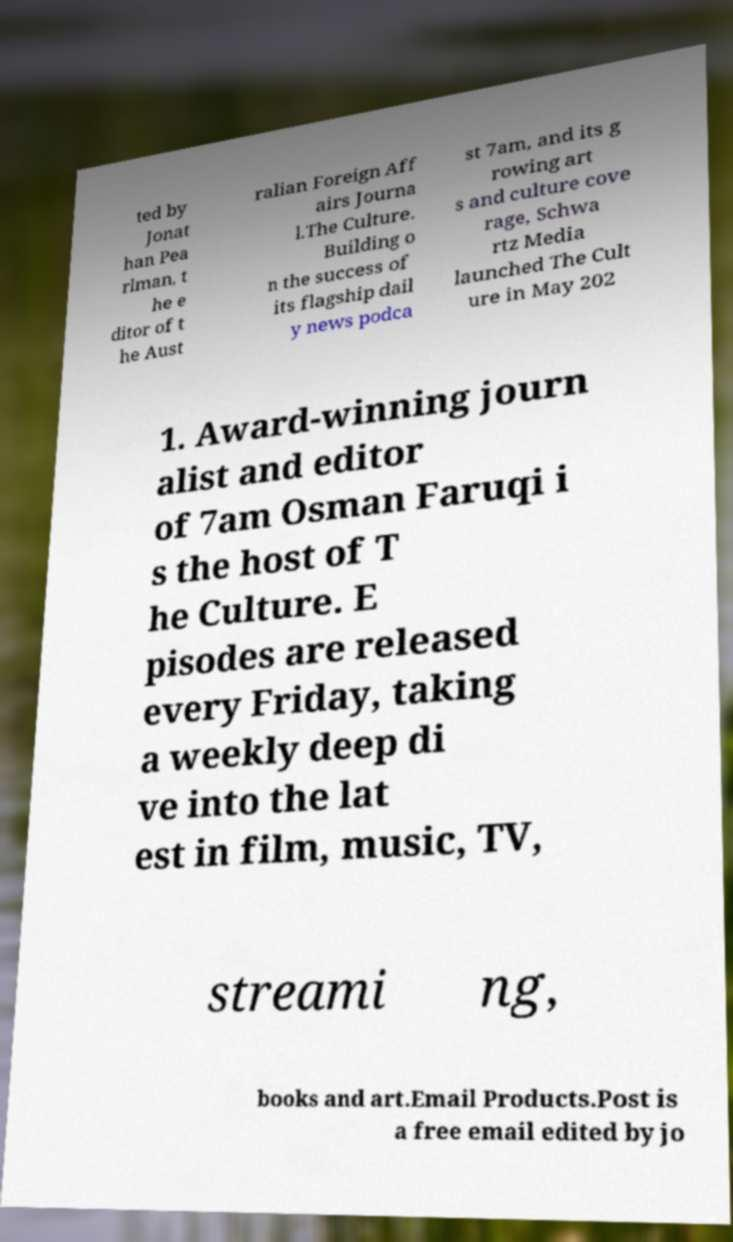Please read and relay the text visible in this image. What does it say? ted by Jonat han Pea rlman, t he e ditor of t he Aust ralian Foreign Aff airs Journa l.The Culture. Building o n the success of its flagship dail y news podca st 7am, and its g rowing art s and culture cove rage, Schwa rtz Media launched The Cult ure in May 202 1. Award-winning journ alist and editor of 7am Osman Faruqi i s the host of T he Culture. E pisodes are released every Friday, taking a weekly deep di ve into the lat est in film, music, TV, streami ng, books and art.Email Products.Post is a free email edited by jo 